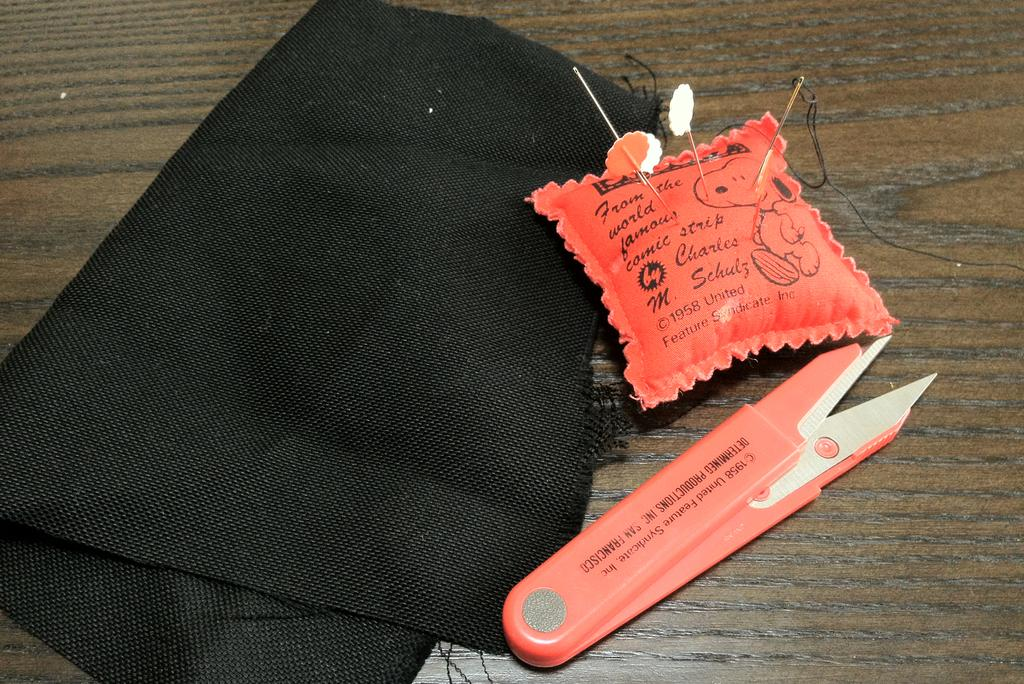Provide a one-sentence caption for the provided image. A red pin cushion says Charles M. Schulz on it and has a picture of Snoopy. 